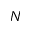<formula> <loc_0><loc_0><loc_500><loc_500>N</formula> 